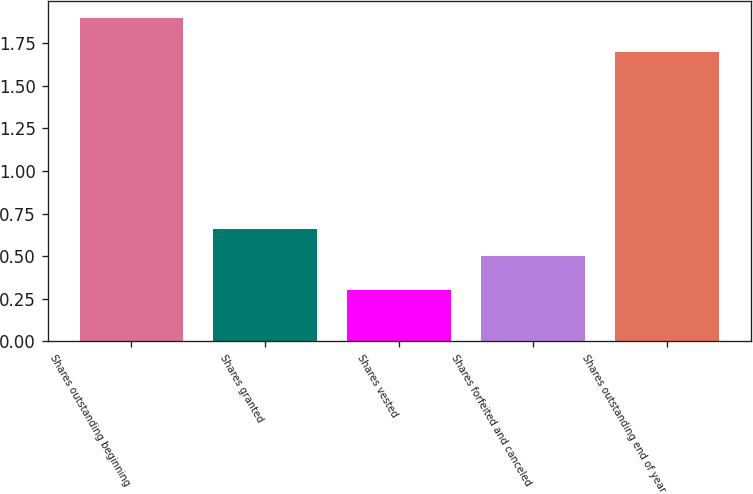Convert chart to OTSL. <chart><loc_0><loc_0><loc_500><loc_500><bar_chart><fcel>Shares outstanding beginning<fcel>Shares granted<fcel>Shares vested<fcel>Shares forfeited and canceled<fcel>Shares outstanding end of year<nl><fcel>1.9<fcel>0.66<fcel>0.3<fcel>0.5<fcel>1.7<nl></chart> 